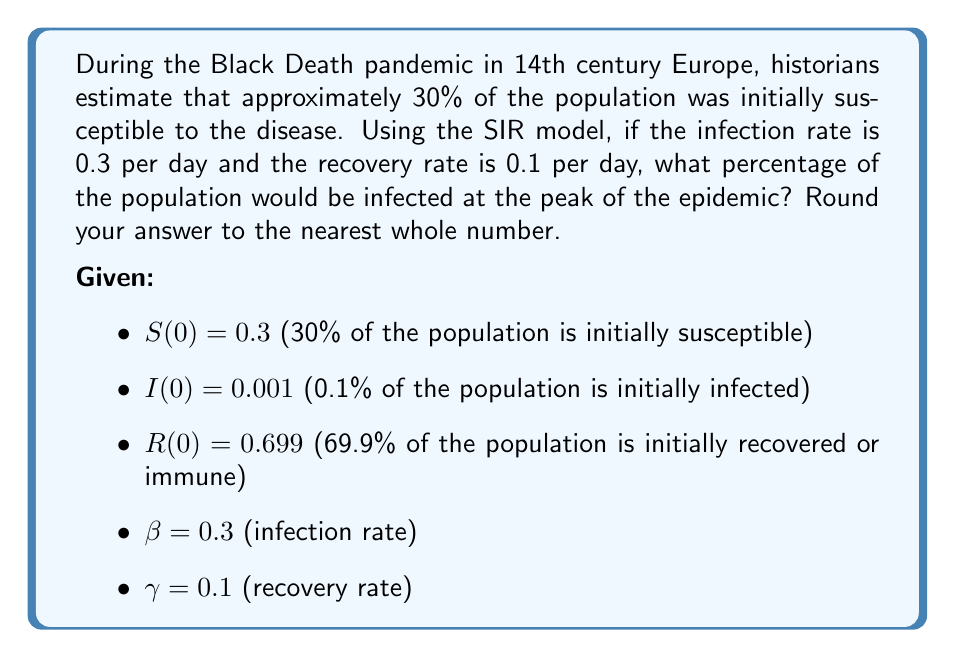Could you help me with this problem? To solve this problem, we'll use the SIR model differential equations and the concept of the basic reproduction number (R₀).

1. The SIR model equations are:

   $$\frac{dS}{dt} = -\beta SI$$
   $$\frac{dI}{dt} = \beta SI - \gamma I$$
   $$\frac{dR}{dt} = \gamma I$$

2. The basic reproduction number R₀ is given by:

   $$R_0 = \frac{\beta}{\gamma} = \frac{0.3}{0.1} = 3$$

3. In the SIR model, the peak of the epidemic occurs when:

   $$S = \frac{1}{R_0} = \frac{1}{3} \approx 0.333$$

4. To find the maximum percentage of infected individuals, we use the conservation of population principle:

   $$S + I + R = 1$$

5. At the peak, S = 1/R₀, so we can write:

   $$\frac{1}{R_0} + I_{max} + R = 1$$

6. Rearranging to solve for I_{max}:

   $$I_{max} = 1 - \frac{1}{R_0} - R$$

7. We need to find R at the peak. We can use the formula:

   $$R = R(0) - S(0) + \frac{1}{R_0}$$

   $$R = 0.699 - 0.3 + \frac{1}{3} \approx 0.732$$

8. Now we can calculate I_{max}:

   $$I_{max} = 1 - \frac{1}{3} - 0.732 \approx 0.268$$

9. Converting to a percentage:

   $$0.268 * 100 \approx 26.8\%$$

10. Rounding to the nearest whole number:

    $$26.8\% \approx 27\%$$
Answer: 27% 